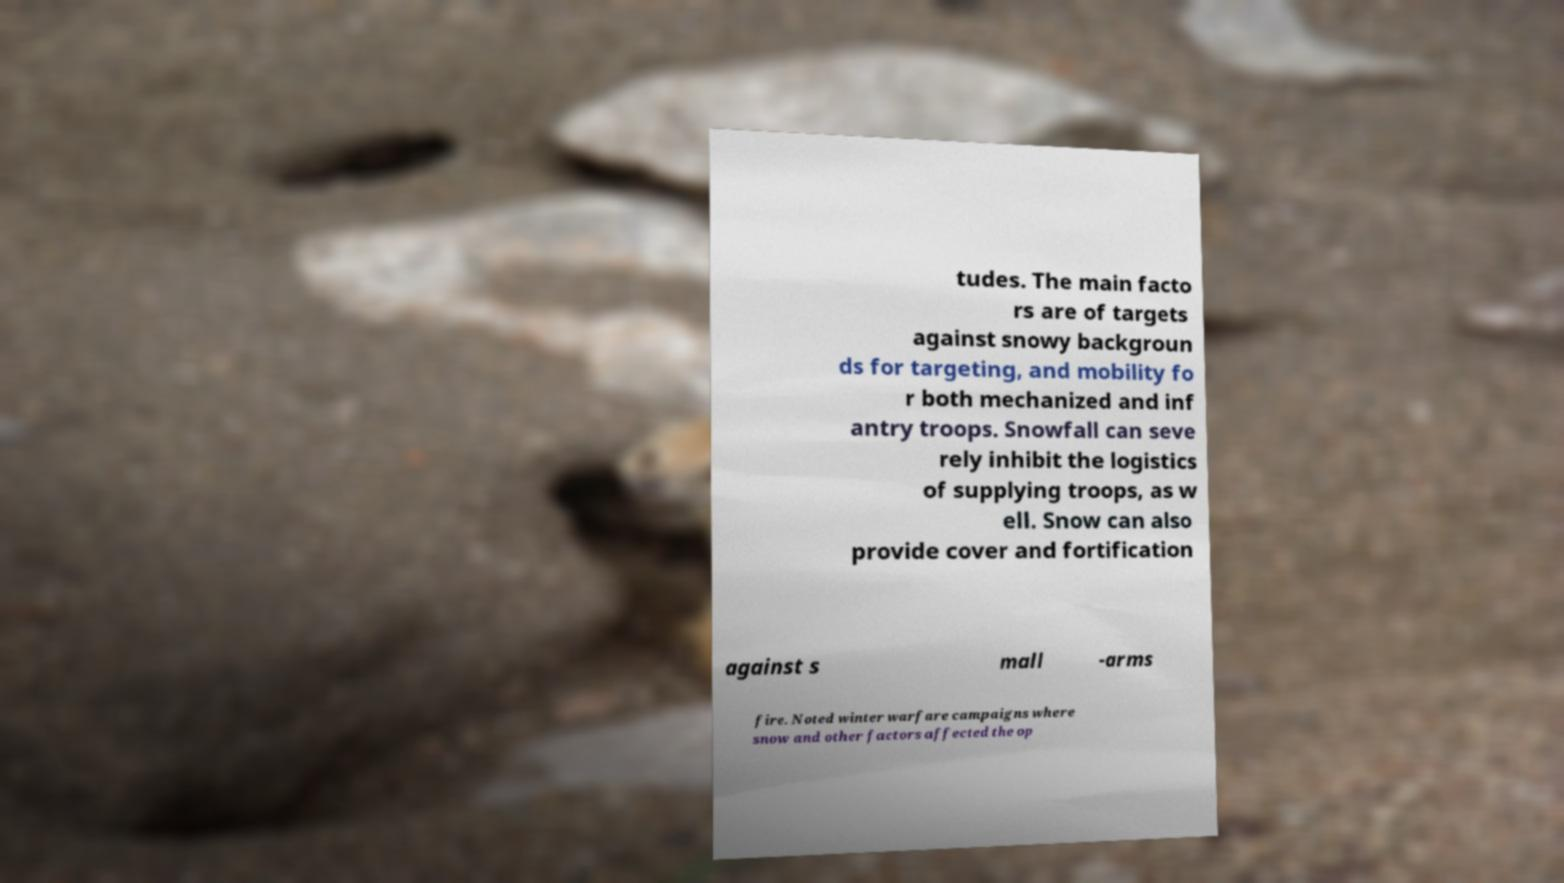Can you read and provide the text displayed in the image?This photo seems to have some interesting text. Can you extract and type it out for me? tudes. The main facto rs are of targets against snowy backgroun ds for targeting, and mobility fo r both mechanized and inf antry troops. Snowfall can seve rely inhibit the logistics of supplying troops, as w ell. Snow can also provide cover and fortification against s mall -arms fire. Noted winter warfare campaigns where snow and other factors affected the op 